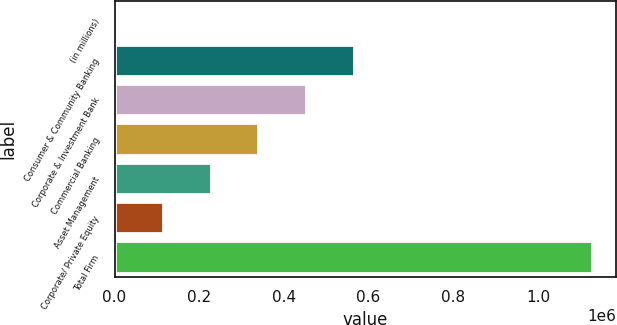Convert chart. <chart><loc_0><loc_0><loc_500><loc_500><bar_chart><fcel>(in millions)<fcel>Consumer & Community Banking<fcel>Corporate & Investment Bank<fcel>Commercial Banking<fcel>Asset Management<fcel>Corporate/ Private Equity<fcel>Total Firm<nl><fcel>2011<fcel>564908<fcel>452329<fcel>339750<fcel>227170<fcel>114590<fcel>1.12781e+06<nl></chart> 